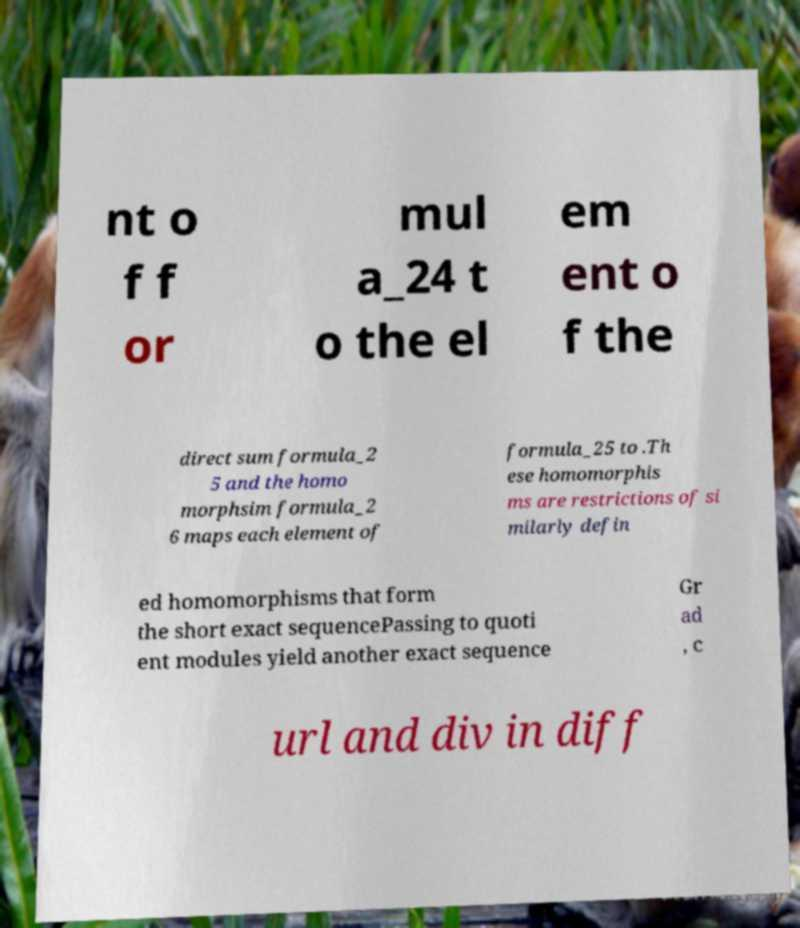What messages or text are displayed in this image? I need them in a readable, typed format. nt o f f or mul a_24 t o the el em ent o f the direct sum formula_2 5 and the homo morphsim formula_2 6 maps each element of formula_25 to .Th ese homomorphis ms are restrictions of si milarly defin ed homomorphisms that form the short exact sequencePassing to quoti ent modules yield another exact sequence Gr ad , c url and div in diff 